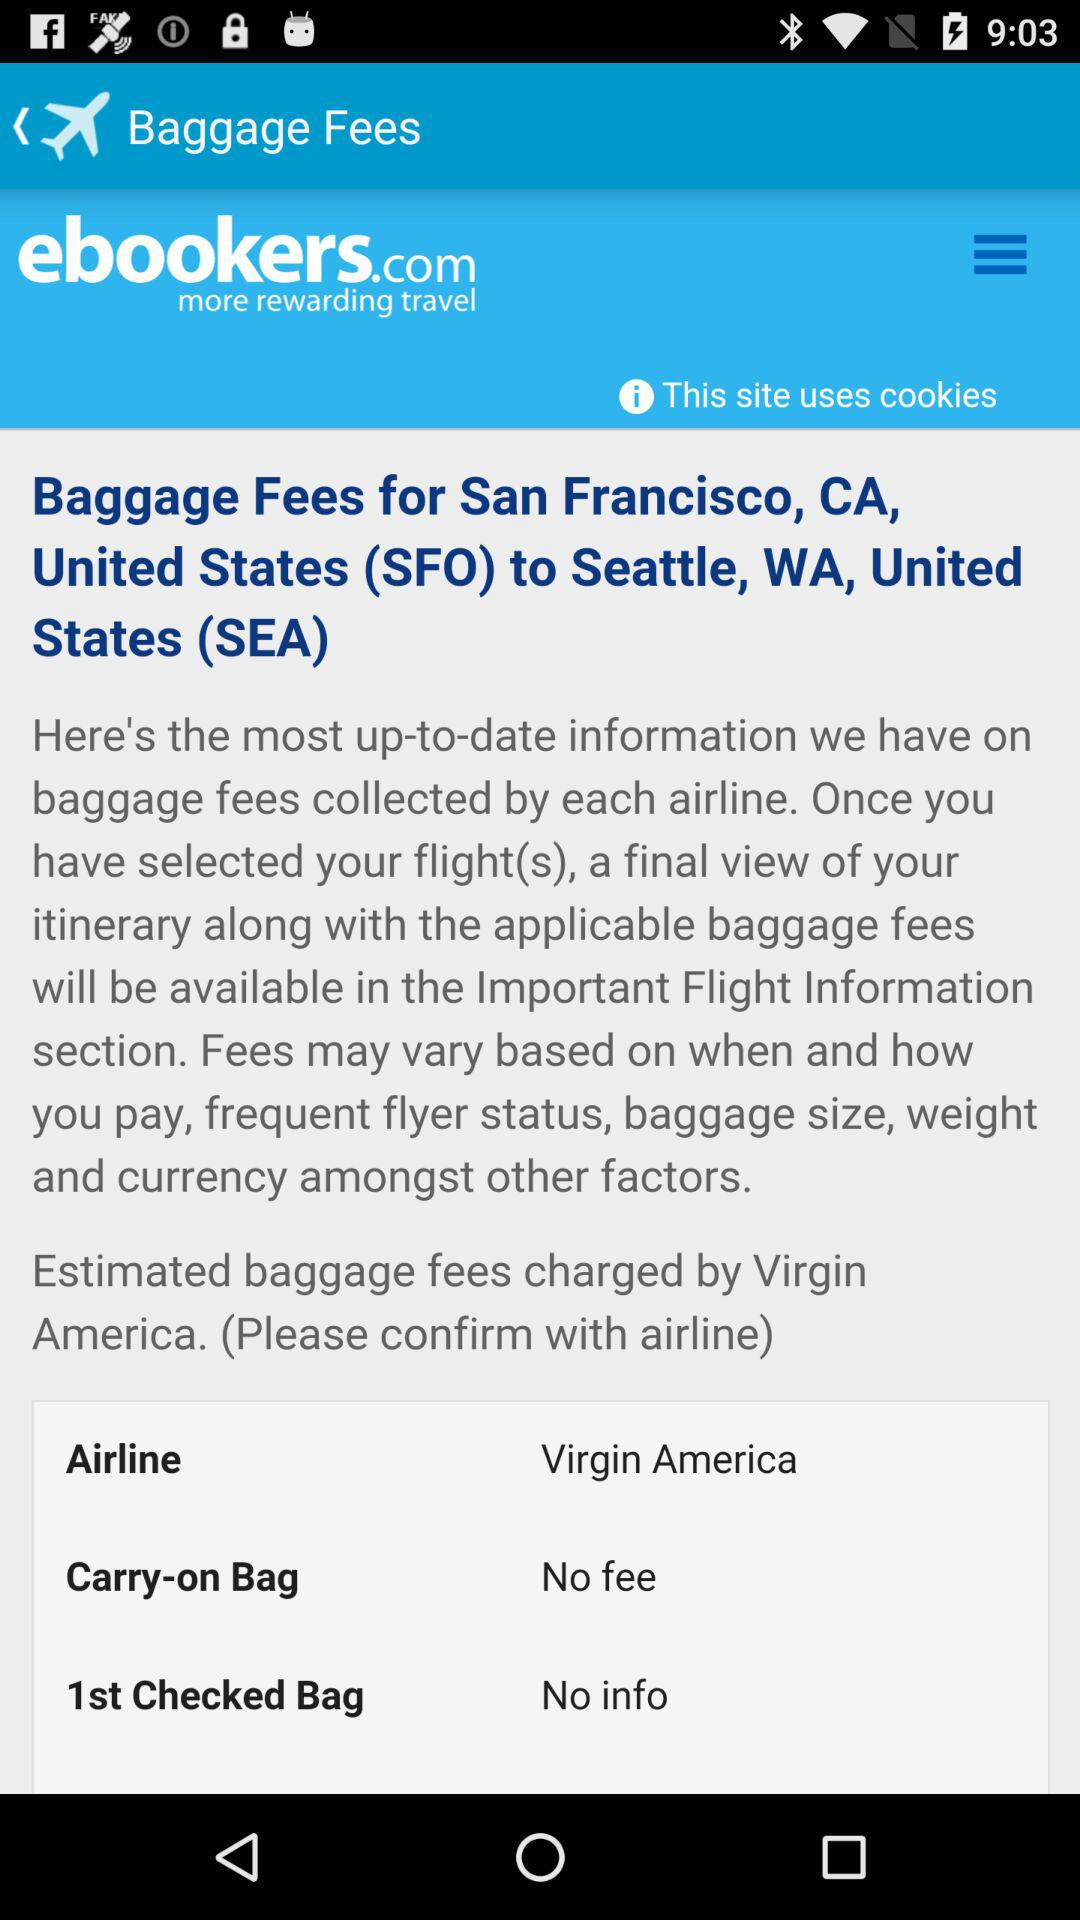What country has been mentioned in relation to baggage fees? The country that has been mentioned in relation to baggage fees is the United States. 